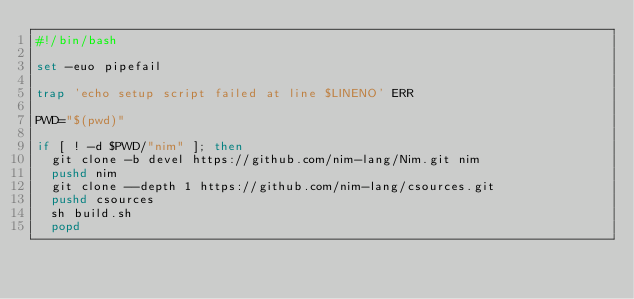<code> <loc_0><loc_0><loc_500><loc_500><_Bash_>#!/bin/bash

set -euo pipefail

trap 'echo setup script failed at line $LINENO' ERR

PWD="$(pwd)"

if [ ! -d $PWD/"nim" ]; then
  git clone -b devel https://github.com/nim-lang/Nim.git nim
  pushd nim
  git clone --depth 1 https://github.com/nim-lang/csources.git
  pushd csources
  sh build.sh
  popd</code> 